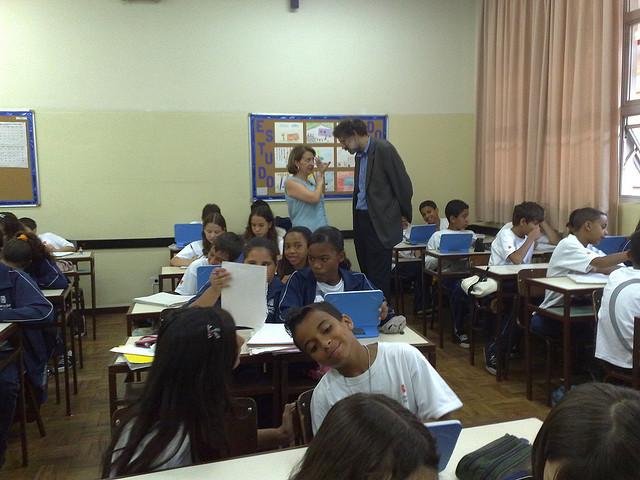What room is this?
Give a very brief answer. Classroom. Are this people old?
Answer briefly. No. What is the race of the teacher?
Keep it brief. White. Are there kids wearing headphones?
Keep it brief. No. Why are the windows open in the classroom?
Short answer required. Hot. How many people in the shot?
Quick response, please. 23. What class are they in?
Write a very short answer. English. Are the lights on?
Answer briefly. Yes. Is this an elementary school?
Quick response, please. Yes. 